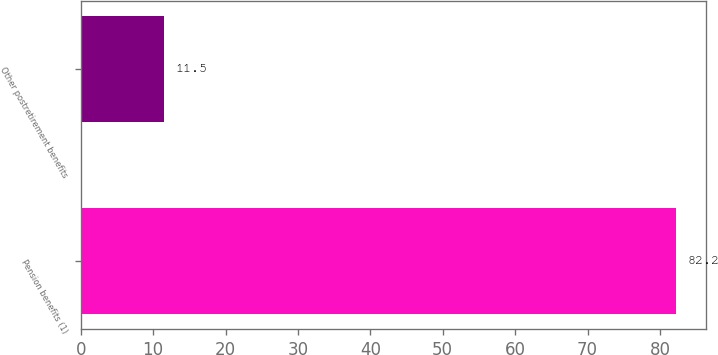Convert chart. <chart><loc_0><loc_0><loc_500><loc_500><bar_chart><fcel>Pension benefits (1)<fcel>Other postretirement benefits<nl><fcel>82.2<fcel>11.5<nl></chart> 